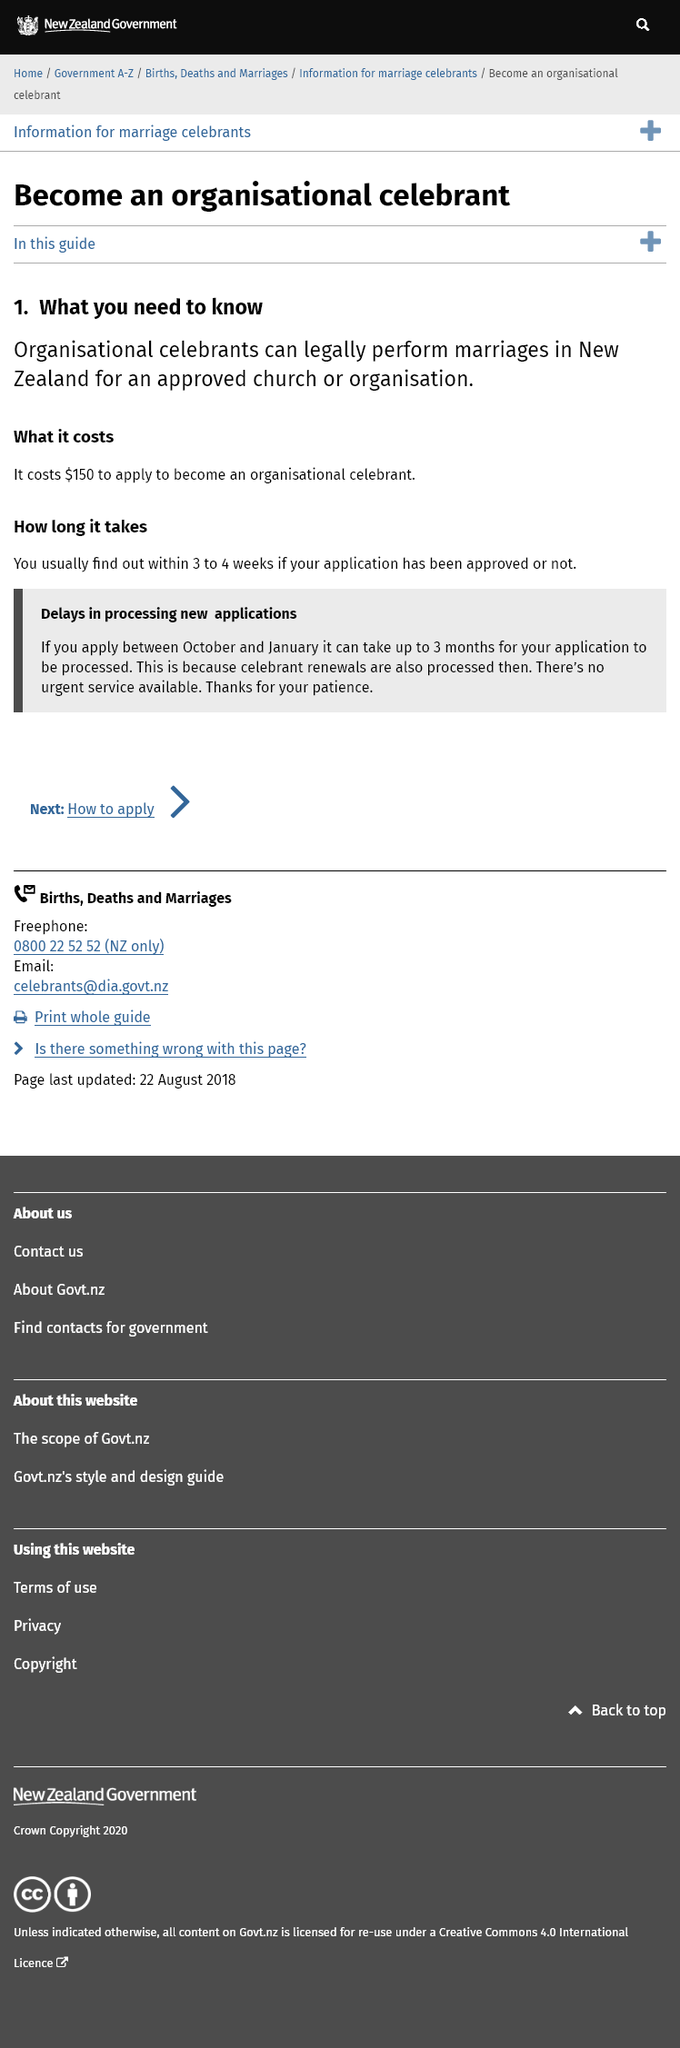Draw attention to some important aspects in this diagram. Being a celebrant in New Zealand allows one to legally perform marriages. The fee for applying to become an organizational celebrant is $150. The application's approval status will be determined within 3 to 4 weeks. 